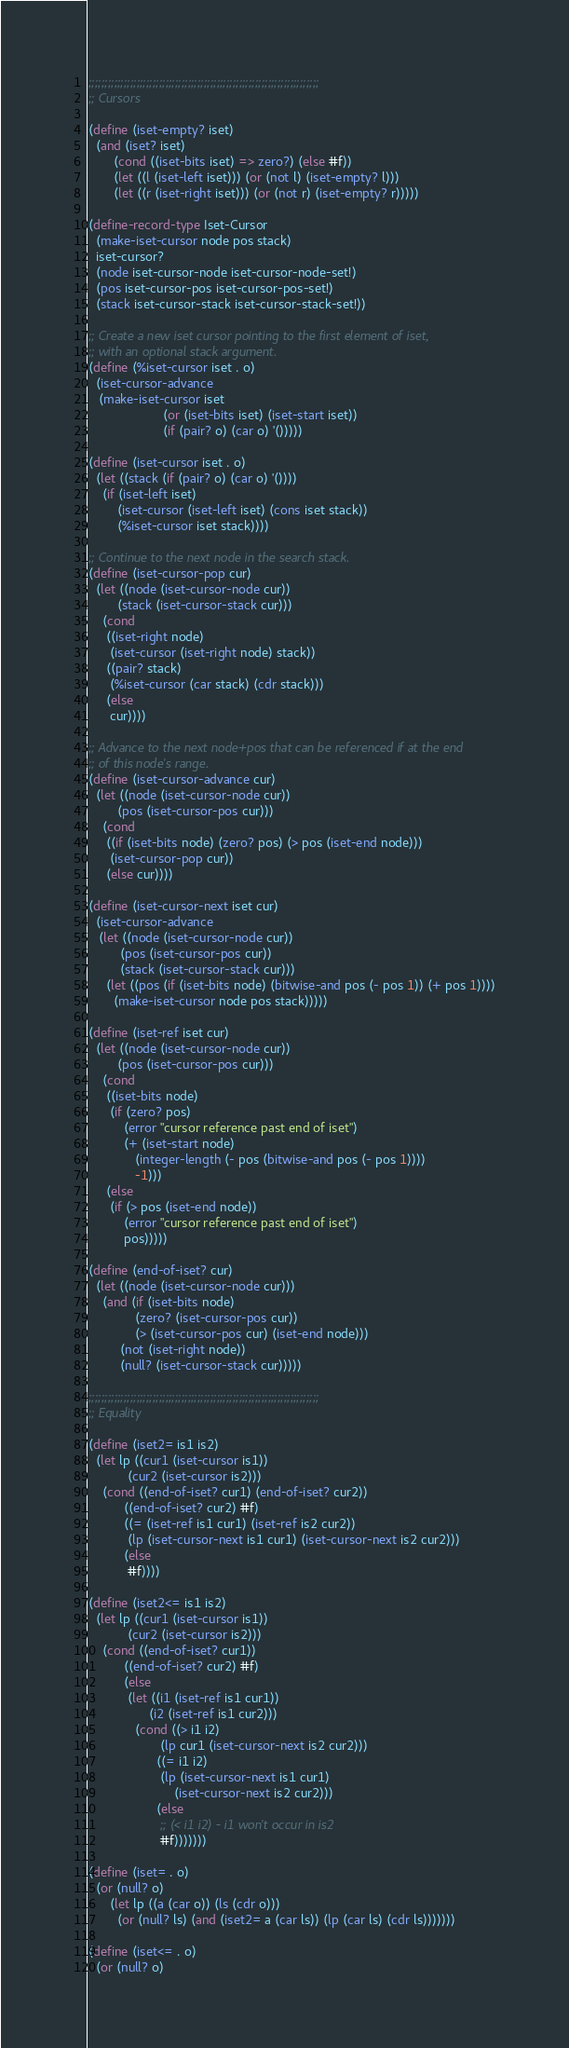Convert code to text. <code><loc_0><loc_0><loc_500><loc_500><_Scheme_>
;;;;;;;;;;;;;;;;;;;;;;;;;;;;;;;;;;;;;;;;;;;;;;;;;;;;;;;;;;;;;;;;;;;;;;;;
;; Cursors

(define (iset-empty? iset)
  (and (iset? iset)
       (cond ((iset-bits iset) => zero?) (else #f))
       (let ((l (iset-left iset))) (or (not l) (iset-empty? l)))
       (let ((r (iset-right iset))) (or (not r) (iset-empty? r)))))

(define-record-type Iset-Cursor
  (make-iset-cursor node pos stack)
  iset-cursor?
  (node iset-cursor-node iset-cursor-node-set!)
  (pos iset-cursor-pos iset-cursor-pos-set!)
  (stack iset-cursor-stack iset-cursor-stack-set!))

;; Create a new iset cursor pointing to the first element of iset,
;; with an optional stack argument.
(define (%iset-cursor iset . o)
  (iset-cursor-advance
   (make-iset-cursor iset
                     (or (iset-bits iset) (iset-start iset))
                     (if (pair? o) (car o) '()))))

(define (iset-cursor iset . o)
  (let ((stack (if (pair? o) (car o) '())))
    (if (iset-left iset)
        (iset-cursor (iset-left iset) (cons iset stack))
        (%iset-cursor iset stack))))

;; Continue to the next node in the search stack.
(define (iset-cursor-pop cur)
  (let ((node (iset-cursor-node cur))
        (stack (iset-cursor-stack cur)))
    (cond
     ((iset-right node)
      (iset-cursor (iset-right node) stack))
     ((pair? stack)
      (%iset-cursor (car stack) (cdr stack)))
     (else
      cur))))

;; Advance to the next node+pos that can be referenced if at the end
;; of this node's range.
(define (iset-cursor-advance cur)
  (let ((node (iset-cursor-node cur))
        (pos (iset-cursor-pos cur)))
    (cond
     ((if (iset-bits node) (zero? pos) (> pos (iset-end node)))
      (iset-cursor-pop cur))
     (else cur))))

(define (iset-cursor-next iset cur)
  (iset-cursor-advance
   (let ((node (iset-cursor-node cur))
         (pos (iset-cursor-pos cur))
         (stack (iset-cursor-stack cur)))
     (let ((pos (if (iset-bits node) (bitwise-and pos (- pos 1)) (+ pos 1))))
       (make-iset-cursor node pos stack)))))

(define (iset-ref iset cur)
  (let ((node (iset-cursor-node cur))
        (pos (iset-cursor-pos cur)))
    (cond
     ((iset-bits node)
      (if (zero? pos)
          (error "cursor reference past end of iset")
          (+ (iset-start node)
             (integer-length (- pos (bitwise-and pos (- pos 1))))
             -1)))
     (else
      (if (> pos (iset-end node))
          (error "cursor reference past end of iset")
          pos)))))

(define (end-of-iset? cur)
  (let ((node (iset-cursor-node cur)))
    (and (if (iset-bits node)
             (zero? (iset-cursor-pos cur))
             (> (iset-cursor-pos cur) (iset-end node)))
         (not (iset-right node))
         (null? (iset-cursor-stack cur)))))

;;;;;;;;;;;;;;;;;;;;;;;;;;;;;;;;;;;;;;;;;;;;;;;;;;;;;;;;;;;;;;;;;;;;;;;;
;; Equality

(define (iset2= is1 is2)
  (let lp ((cur1 (iset-cursor is1))
           (cur2 (iset-cursor is2)))
    (cond ((end-of-iset? cur1) (end-of-iset? cur2))
          ((end-of-iset? cur2) #f)
          ((= (iset-ref is1 cur1) (iset-ref is2 cur2))
           (lp (iset-cursor-next is1 cur1) (iset-cursor-next is2 cur2)))
          (else
           #f))))

(define (iset2<= is1 is2)
  (let lp ((cur1 (iset-cursor is1))
           (cur2 (iset-cursor is2)))
    (cond ((end-of-iset? cur1))
          ((end-of-iset? cur2) #f)
          (else
           (let ((i1 (iset-ref is1 cur1))
                 (i2 (iset-ref is1 cur2)))
             (cond ((> i1 i2)
                    (lp cur1 (iset-cursor-next is2 cur2)))
                   ((= i1 i2)
                    (lp (iset-cursor-next is1 cur1)
                        (iset-cursor-next is2 cur2)))
                   (else
                    ;; (< i1 i2) - i1 won't occur in is2
                    #f)))))))

(define (iset= . o)
  (or (null? o)
      (let lp ((a (car o)) (ls (cdr o)))
        (or (null? ls) (and (iset2= a (car ls)) (lp (car ls) (cdr ls)))))))

(define (iset<= . o)
  (or (null? o)</code> 